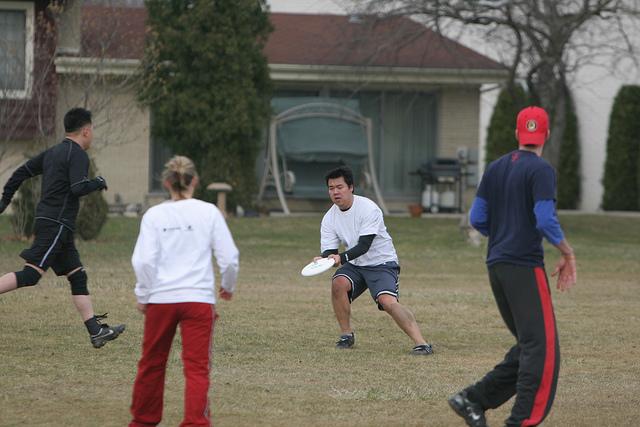What are they playing?
Write a very short answer. Frisbee. What game is being played?
Give a very brief answer. Frisbee. Is someone wearing a hat?
Be succinct. Yes. Which man has bad knees?
Short answer required. Man on left. What is the gender of the person in the  red pants?
Quick response, please. Female. What is directly behind the players?
Keep it brief. House. 